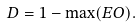<formula> <loc_0><loc_0><loc_500><loc_500>D = 1 - \max ( E O ) .</formula> 